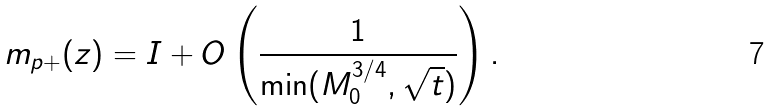Convert formula to latex. <formula><loc_0><loc_0><loc_500><loc_500>m _ { p + } ( z ) = I + O \left ( \frac { 1 } { \min ( M _ { 0 } ^ { 3 / 4 } , \sqrt { t } ) } \right ) .</formula> 